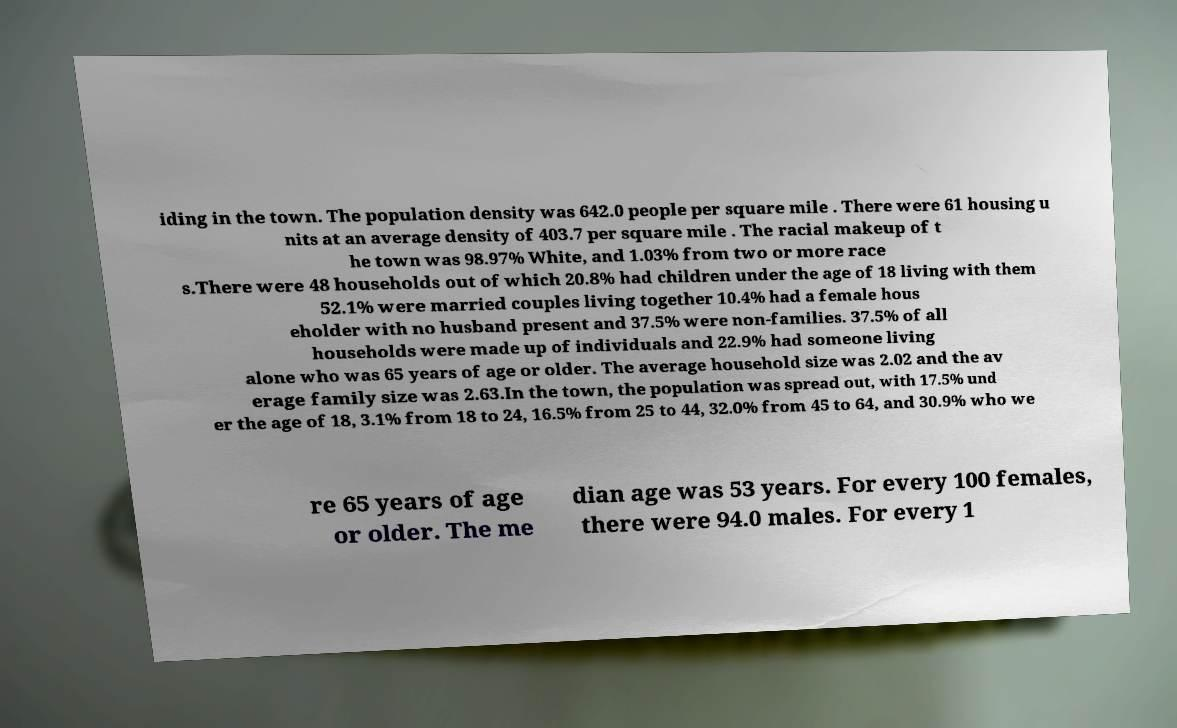Can you read and provide the text displayed in the image?This photo seems to have some interesting text. Can you extract and type it out for me? iding in the town. The population density was 642.0 people per square mile . There were 61 housing u nits at an average density of 403.7 per square mile . The racial makeup of t he town was 98.97% White, and 1.03% from two or more race s.There were 48 households out of which 20.8% had children under the age of 18 living with them 52.1% were married couples living together 10.4% had a female hous eholder with no husband present and 37.5% were non-families. 37.5% of all households were made up of individuals and 22.9% had someone living alone who was 65 years of age or older. The average household size was 2.02 and the av erage family size was 2.63.In the town, the population was spread out, with 17.5% und er the age of 18, 3.1% from 18 to 24, 16.5% from 25 to 44, 32.0% from 45 to 64, and 30.9% who we re 65 years of age or older. The me dian age was 53 years. For every 100 females, there were 94.0 males. For every 1 